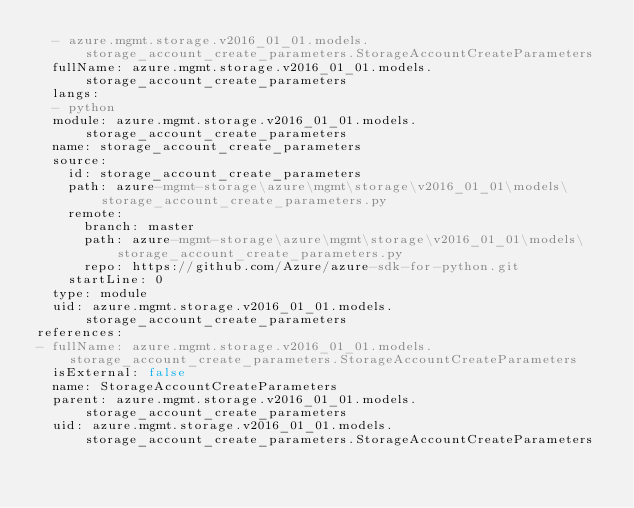<code> <loc_0><loc_0><loc_500><loc_500><_YAML_>  - azure.mgmt.storage.v2016_01_01.models.storage_account_create_parameters.StorageAccountCreateParameters
  fullName: azure.mgmt.storage.v2016_01_01.models.storage_account_create_parameters
  langs:
  - python
  module: azure.mgmt.storage.v2016_01_01.models.storage_account_create_parameters
  name: storage_account_create_parameters
  source:
    id: storage_account_create_parameters
    path: azure-mgmt-storage\azure\mgmt\storage\v2016_01_01\models\storage_account_create_parameters.py
    remote:
      branch: master
      path: azure-mgmt-storage\azure\mgmt\storage\v2016_01_01\models\storage_account_create_parameters.py
      repo: https://github.com/Azure/azure-sdk-for-python.git
    startLine: 0
  type: module
  uid: azure.mgmt.storage.v2016_01_01.models.storage_account_create_parameters
references:
- fullName: azure.mgmt.storage.v2016_01_01.models.storage_account_create_parameters.StorageAccountCreateParameters
  isExternal: false
  name: StorageAccountCreateParameters
  parent: azure.mgmt.storage.v2016_01_01.models.storage_account_create_parameters
  uid: azure.mgmt.storage.v2016_01_01.models.storage_account_create_parameters.StorageAccountCreateParameters
</code> 